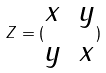<formula> <loc_0><loc_0><loc_500><loc_500>Z = ( \begin{matrix} x & y \\ y & x \end{matrix} )</formula> 